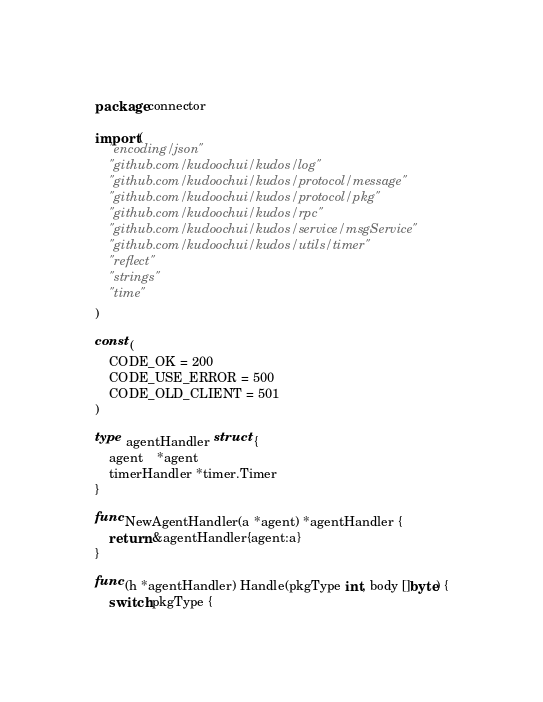<code> <loc_0><loc_0><loc_500><loc_500><_Go_>package connector

import (
	"encoding/json"
	"github.com/kudoochui/kudos/log"
	"github.com/kudoochui/kudos/protocol/message"
	"github.com/kudoochui/kudos/protocol/pkg"
	"github.com/kudoochui/kudos/rpc"
	"github.com/kudoochui/kudos/service/msgService"
	"github.com/kudoochui/kudos/utils/timer"
	"reflect"
	"strings"
	"time"
)

const (
	CODE_OK = 200
	CODE_USE_ERROR = 500
	CODE_OLD_CLIENT = 501
)

type agentHandler struct {
	agent 	*agent
	timerHandler *timer.Timer
}

func NewAgentHandler(a *agent) *agentHandler {
	return &agentHandler{agent:a}
}

func (h *agentHandler) Handle(pkgType int, body []byte) {
	switch pkgType {</code> 